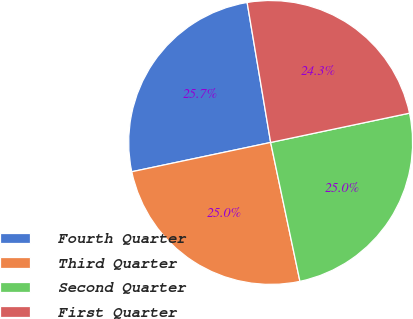Convert chart to OTSL. <chart><loc_0><loc_0><loc_500><loc_500><pie_chart><fcel>Fourth Quarter<fcel>Third Quarter<fcel>Second Quarter<fcel>First Quarter<nl><fcel>25.66%<fcel>25.0%<fcel>25.0%<fcel>24.34%<nl></chart> 